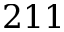Convert formula to latex. <formula><loc_0><loc_0><loc_500><loc_500>2 1 1</formula> 